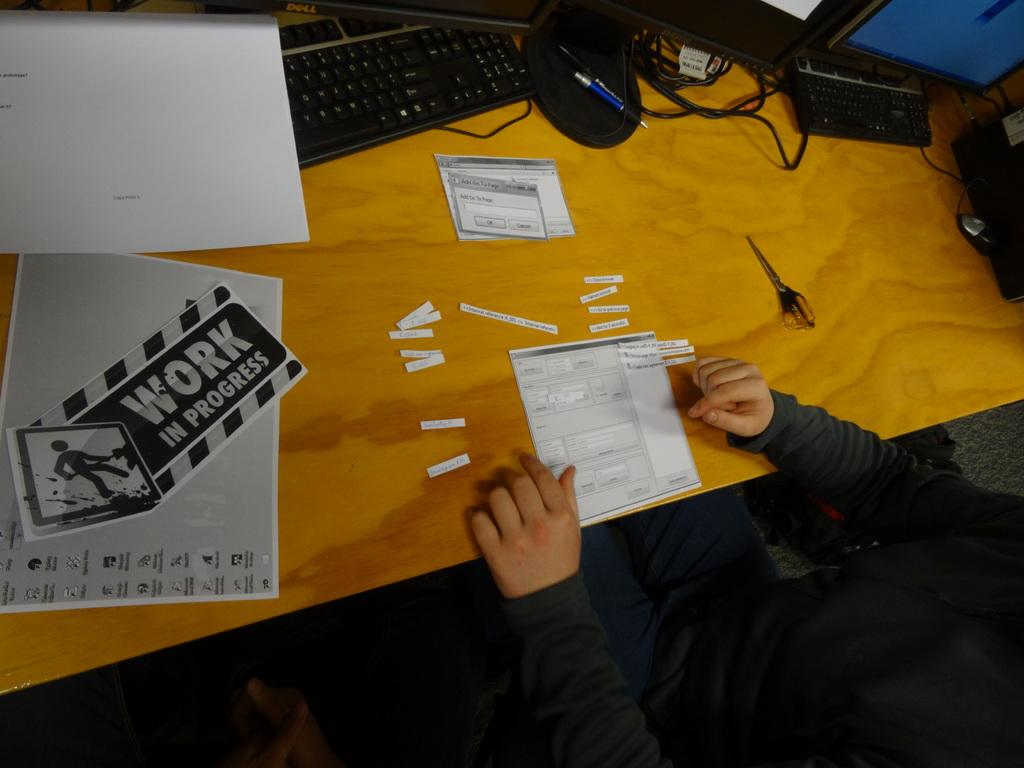<image>
Create a compact narrative representing the image presented. A person is cutting paper at a desk with a sign that says Work In Progress. 